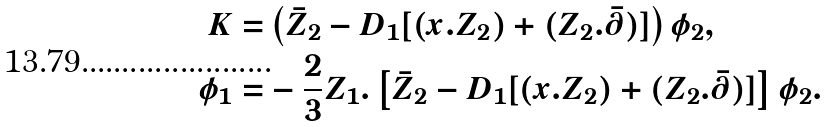Convert formula to latex. <formula><loc_0><loc_0><loc_500><loc_500>K = & \left ( \bar { Z } _ { 2 } - D _ { 1 } [ ( x . Z _ { 2 } ) + ( Z _ { 2 } . \bar { \partial } ) ] \right ) \phi _ { 2 } , \\ \phi _ { 1 } = & - \frac { 2 } { 3 } { Z _ { 1 } } . \left [ \bar { Z } _ { 2 } - D _ { 1 } [ ( x . Z _ { 2 } ) + ( Z _ { 2 } . \bar { \partial } ) ] \right ] \phi _ { 2 } .</formula> 